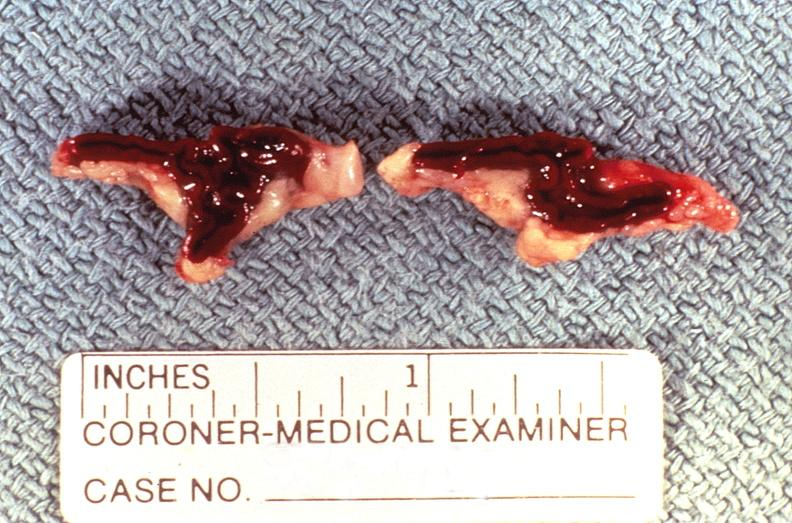what does this image show?
Answer the question using a single word or phrase. Adrenal gland 